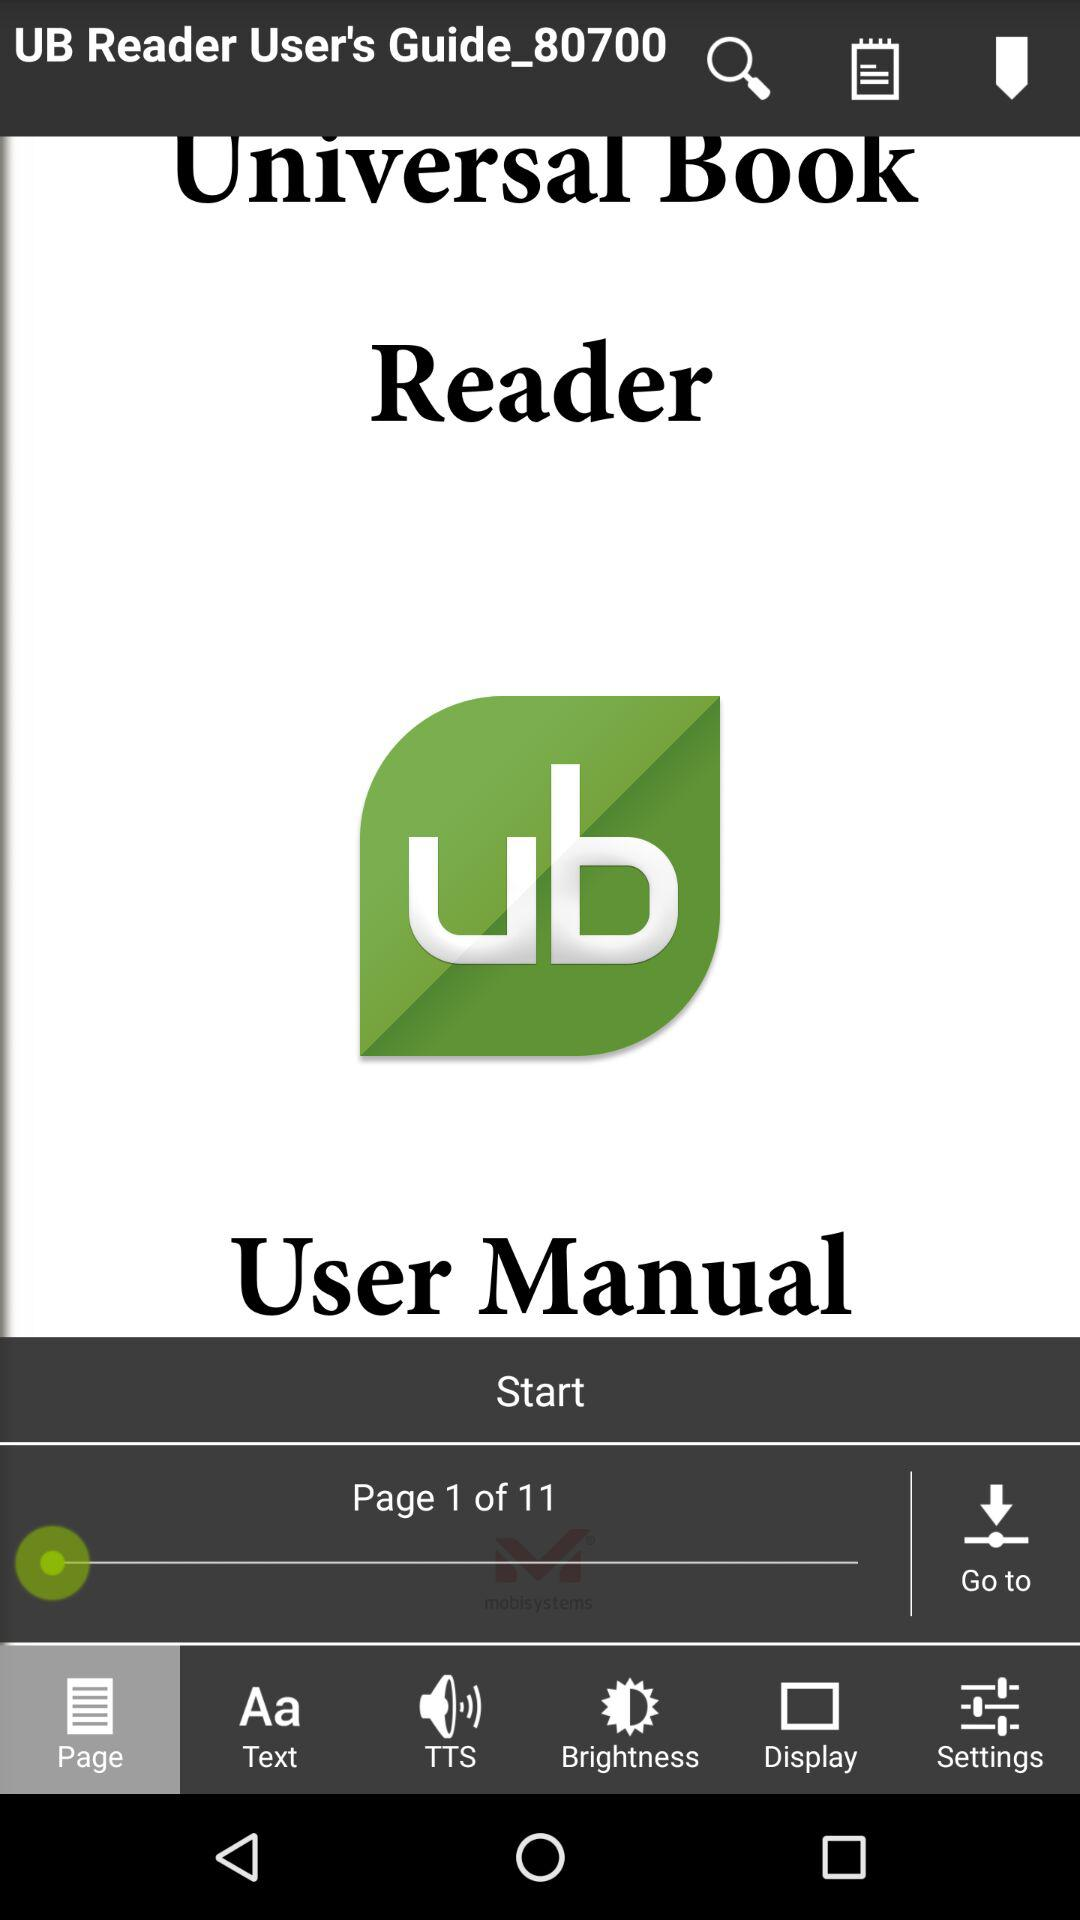On which page number are we now? You are on page number 1. 